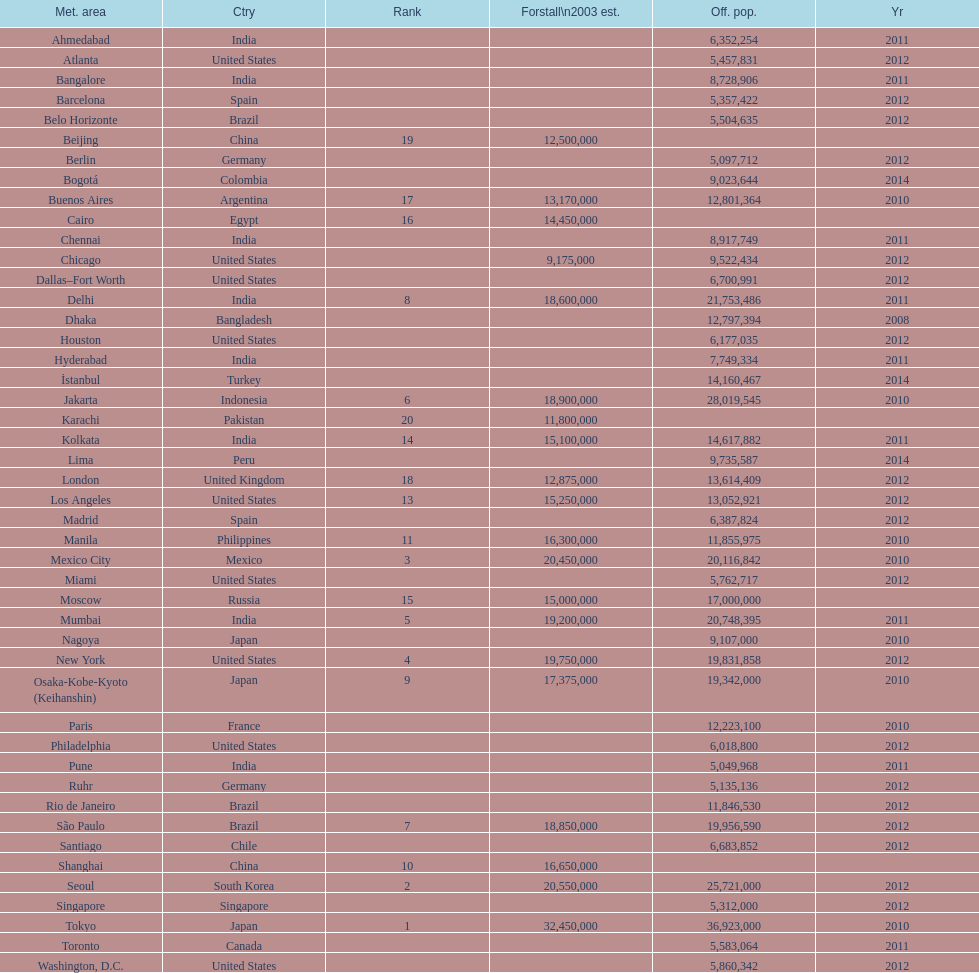Which population is listed before 5,357,422? 8,728,906. 